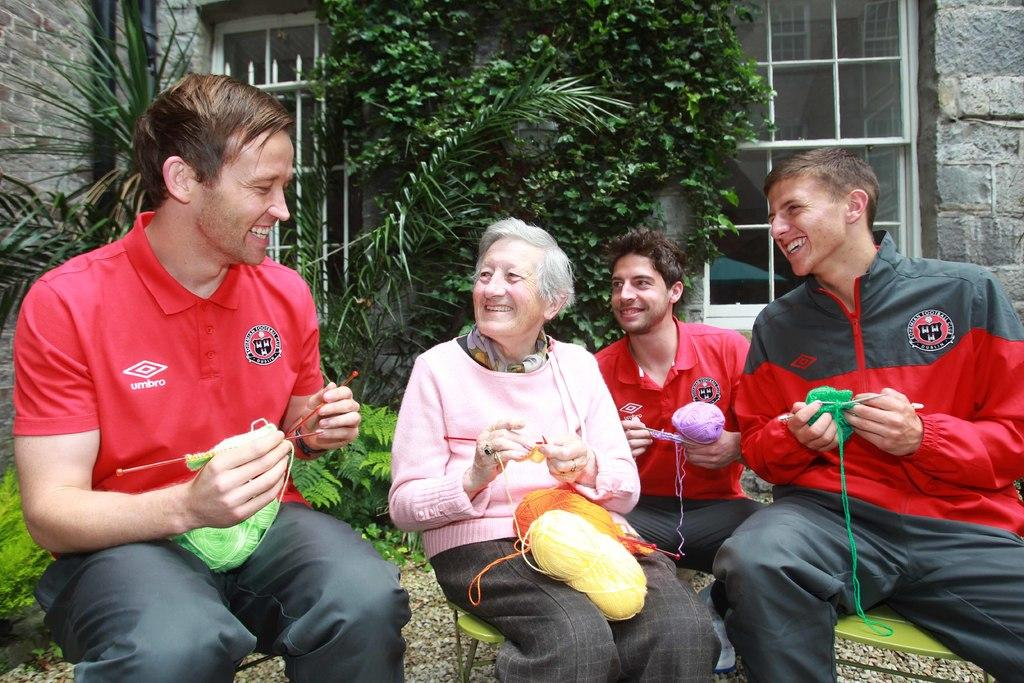What are the people in the image doing? The people in the image are sitting. What object can be seen in the image besides the people? There is a wool bundle in the image. What can be seen in the background of the image? There are trees in the background of the image. What type of building is present in the image? There is a building with stones in the image. What material is used for the window in the image? There is a glass window in the image. What type of pollution can be seen in the image? There is no pollution visible in the image. What verse is being recited by the people in the image? There is no indication that the people in the image are reciting a verse. 